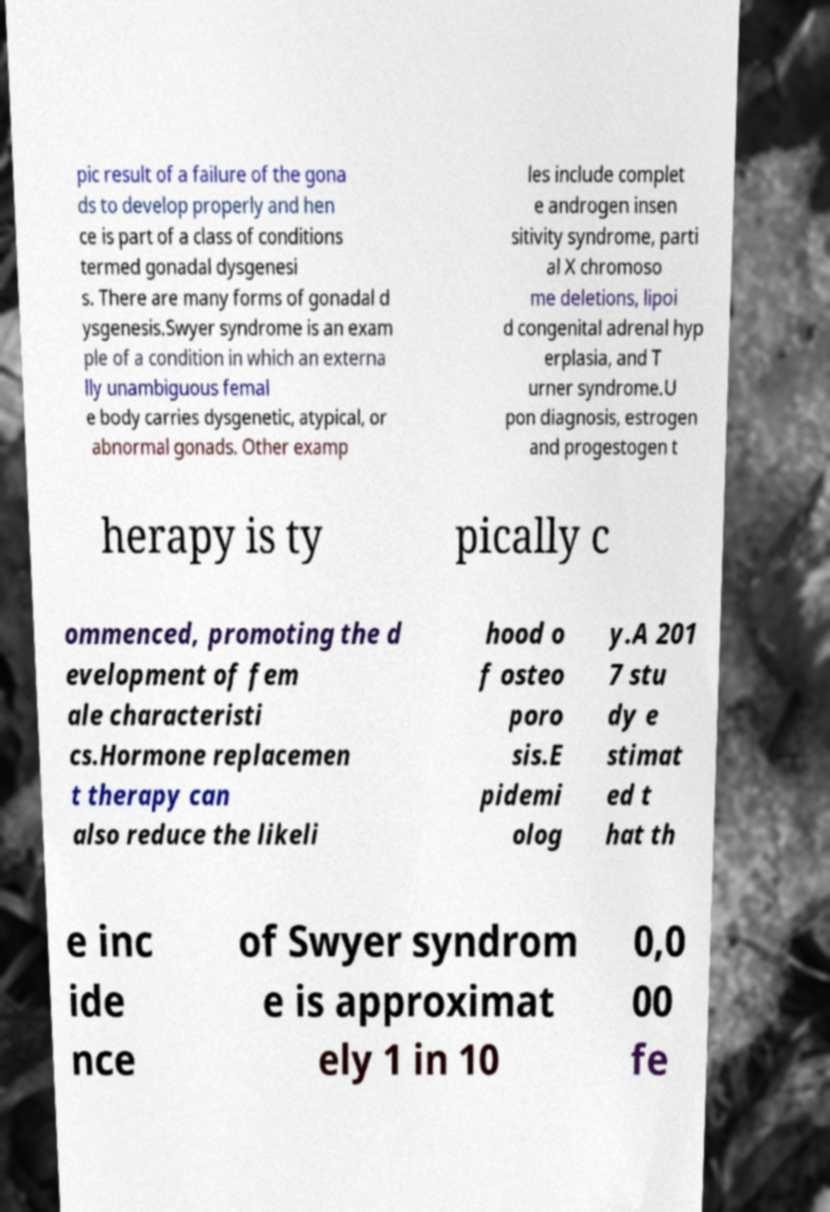I need the written content from this picture converted into text. Can you do that? pic result of a failure of the gona ds to develop properly and hen ce is part of a class of conditions termed gonadal dysgenesi s. There are many forms of gonadal d ysgenesis.Swyer syndrome is an exam ple of a condition in which an externa lly unambiguous femal e body carries dysgenetic, atypical, or abnormal gonads. Other examp les include complet e androgen insen sitivity syndrome, parti al X chromoso me deletions, lipoi d congenital adrenal hyp erplasia, and T urner syndrome.U pon diagnosis, estrogen and progestogen t herapy is ty pically c ommenced, promoting the d evelopment of fem ale characteristi cs.Hormone replacemen t therapy can also reduce the likeli hood o f osteo poro sis.E pidemi olog y.A 201 7 stu dy e stimat ed t hat th e inc ide nce of Swyer syndrom e is approximat ely 1 in 10 0,0 00 fe 